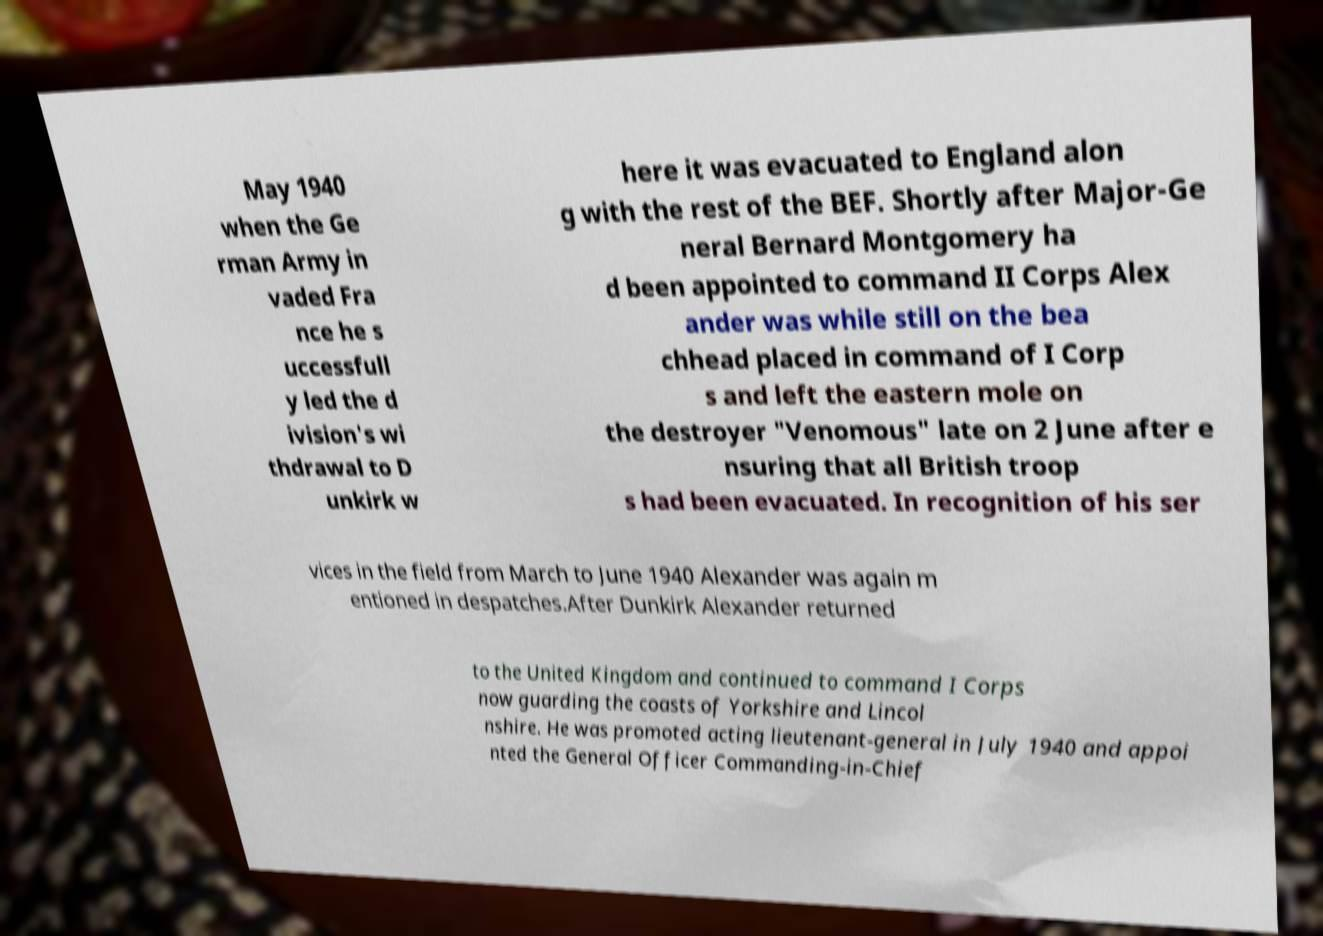Please identify and transcribe the text found in this image. May 1940 when the Ge rman Army in vaded Fra nce he s uccessfull y led the d ivision's wi thdrawal to D unkirk w here it was evacuated to England alon g with the rest of the BEF. Shortly after Major-Ge neral Bernard Montgomery ha d been appointed to command II Corps Alex ander was while still on the bea chhead placed in command of I Corp s and left the eastern mole on the destroyer "Venomous" late on 2 June after e nsuring that all British troop s had been evacuated. In recognition of his ser vices in the field from March to June 1940 Alexander was again m entioned in despatches.After Dunkirk Alexander returned to the United Kingdom and continued to command I Corps now guarding the coasts of Yorkshire and Lincol nshire. He was promoted acting lieutenant-general in July 1940 and appoi nted the General Officer Commanding-in-Chief 